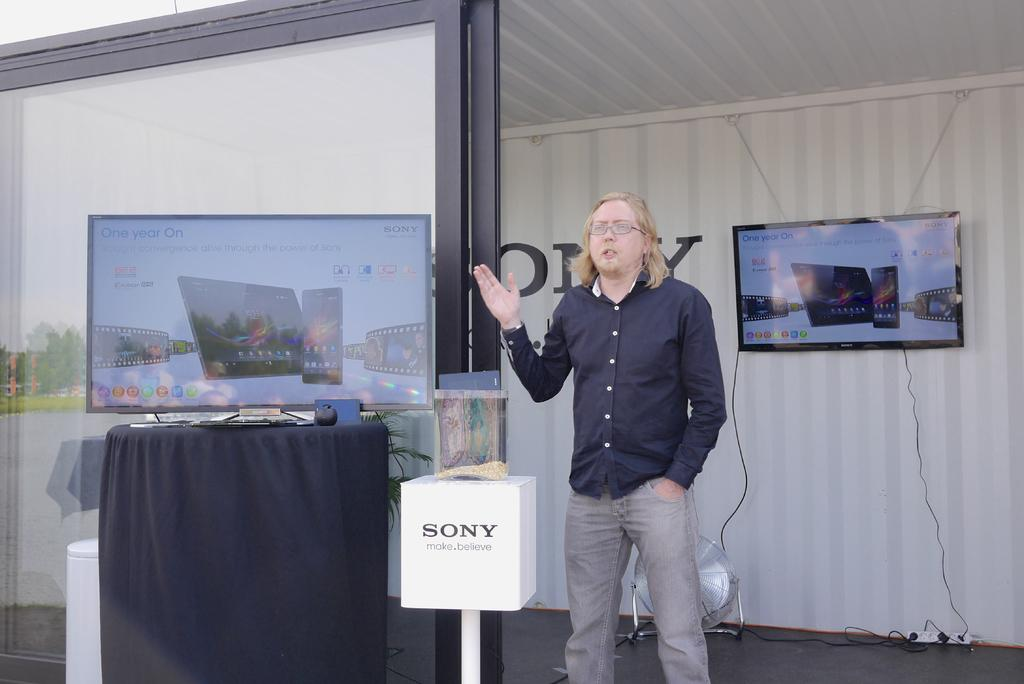<image>
Share a concise interpretation of the image provided. A man standing outdoors next to a Sony digitial display. 